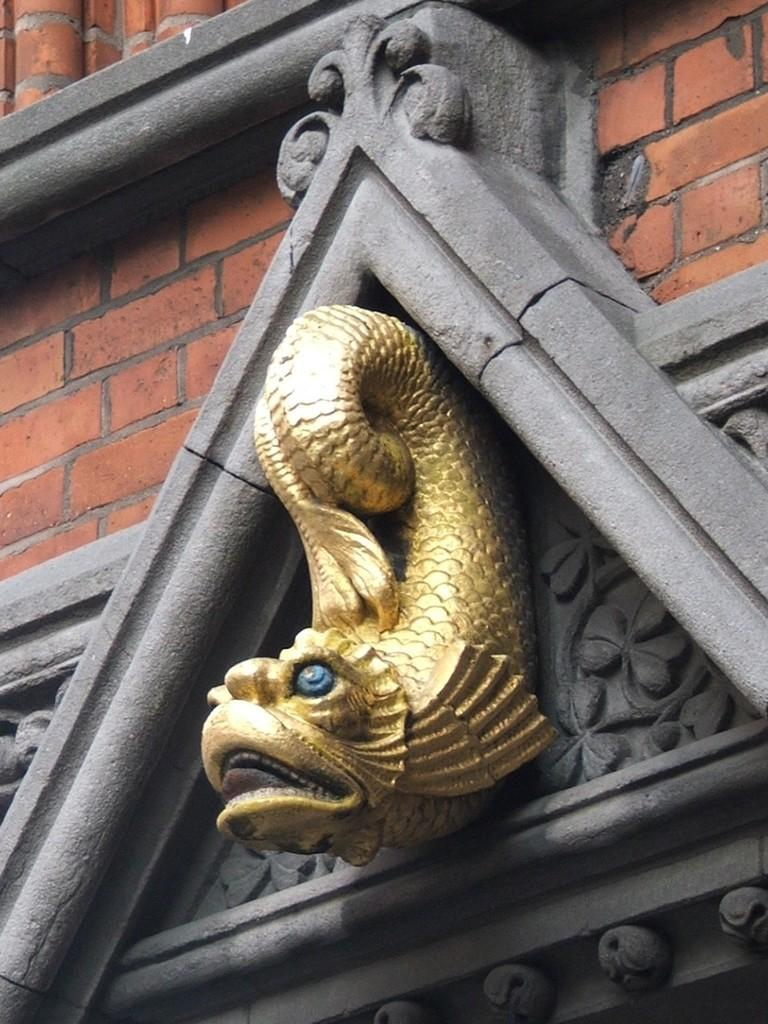What type of object is the main subject of the image? There is a gold color sculpture in the image. Can you describe the shape of the sculpture? The sculpture is in the shape of an arch. What other element can be seen in the image? There is a brick wall in the image. What type of vessel is being used by the doll in the image? There is no vessel or doll present in the image; it features a gold color sculpture in the shape of an arch and a brick wall. 